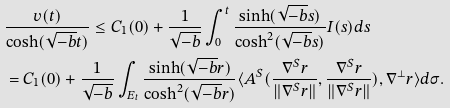Convert formula to latex. <formula><loc_0><loc_0><loc_500><loc_500>& \frac { v ( t ) } { \cosh ( \sqrt { - b } t ) } \leq C _ { 1 } ( 0 ) + \frac { 1 } { \sqrt { - b } } \int _ { 0 } ^ { t } \frac { \sinh ( \sqrt { - b } s ) } { \cosh ^ { 2 } ( \sqrt { - b } s ) } I ( s ) d s \\ & = C _ { 1 } ( 0 ) + \frac { 1 } { \sqrt { - b } } \int _ { E _ { t } } \frac { \sinh ( \sqrt { - b } r ) } { \cosh ^ { 2 } ( \sqrt { - b } r ) } \langle A ^ { S } ( \frac { \nabla ^ { S } r } { \| \nabla ^ { S } r \| } , \frac { \nabla ^ { S } r } { \| \nabla ^ { S } r \| } ) , \nabla ^ { \bot } r \rangle d \sigma . \\</formula> 